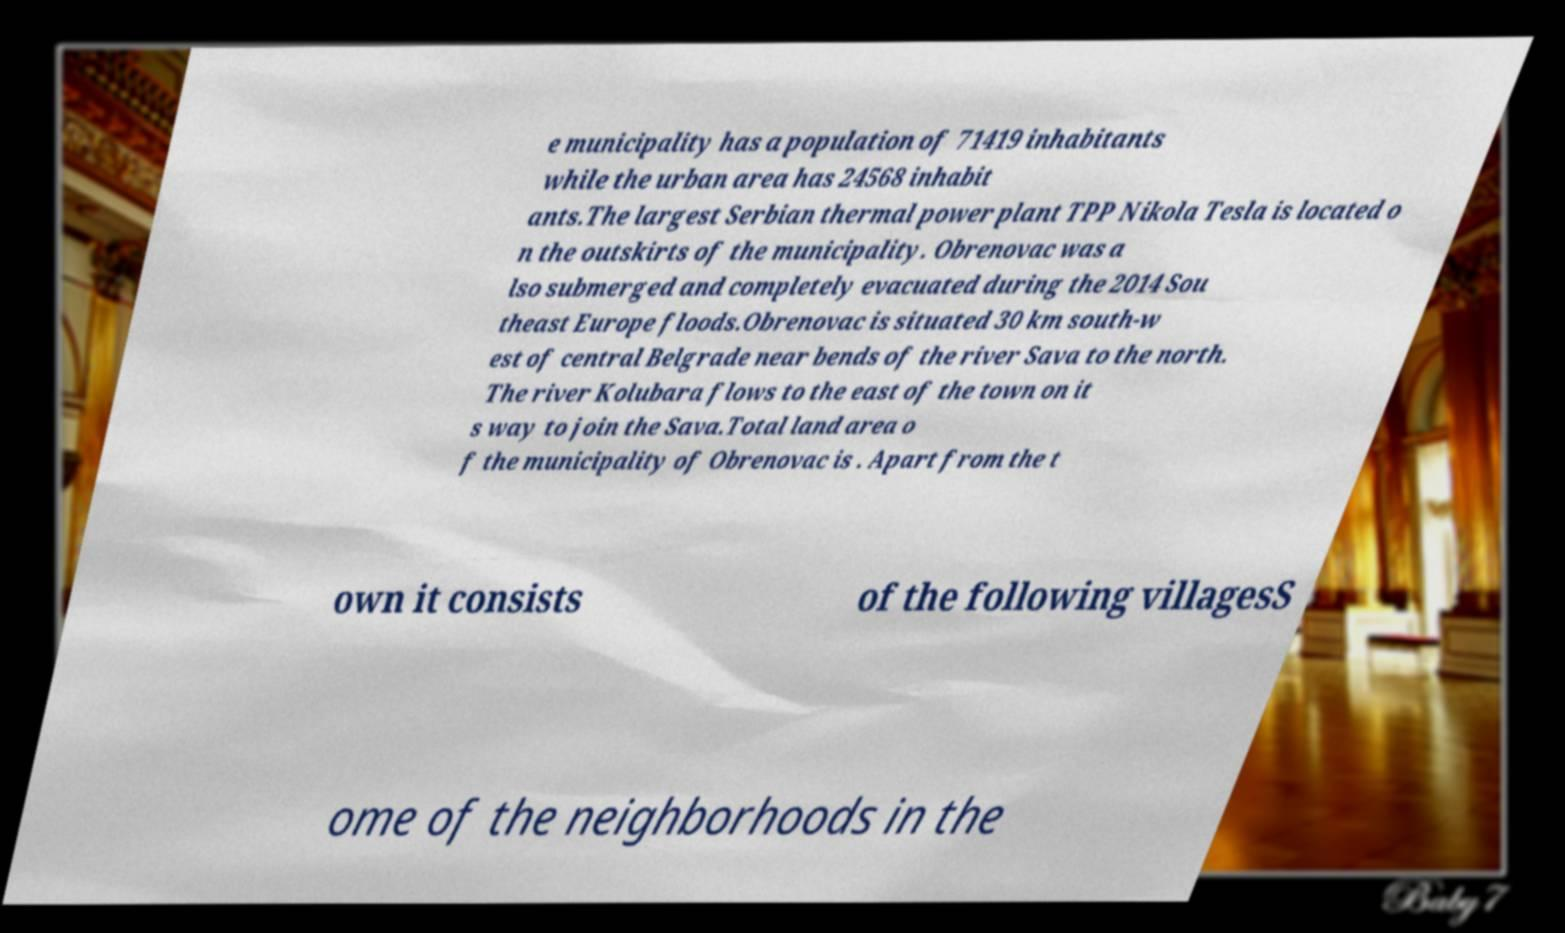Can you accurately transcribe the text from the provided image for me? e municipality has a population of 71419 inhabitants while the urban area has 24568 inhabit ants.The largest Serbian thermal power plant TPP Nikola Tesla is located o n the outskirts of the municipality. Obrenovac was a lso submerged and completely evacuated during the 2014 Sou theast Europe floods.Obrenovac is situated 30 km south-w est of central Belgrade near bends of the river Sava to the north. The river Kolubara flows to the east of the town on it s way to join the Sava.Total land area o f the municipality of Obrenovac is . Apart from the t own it consists of the following villagesS ome of the neighborhoods in the 